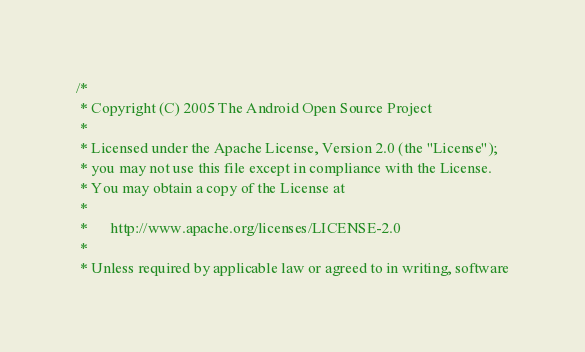Convert code to text. <code><loc_0><loc_0><loc_500><loc_500><_C_>/*
 * Copyright (C) 2005 The Android Open Source Project
 *
 * Licensed under the Apache License, Version 2.0 (the "License");
 * you may not use this file except in compliance with the License.
 * You may obtain a copy of the License at
 *
 *      http://www.apache.org/licenses/LICENSE-2.0
 *
 * Unless required by applicable law or agreed to in writing, software</code> 